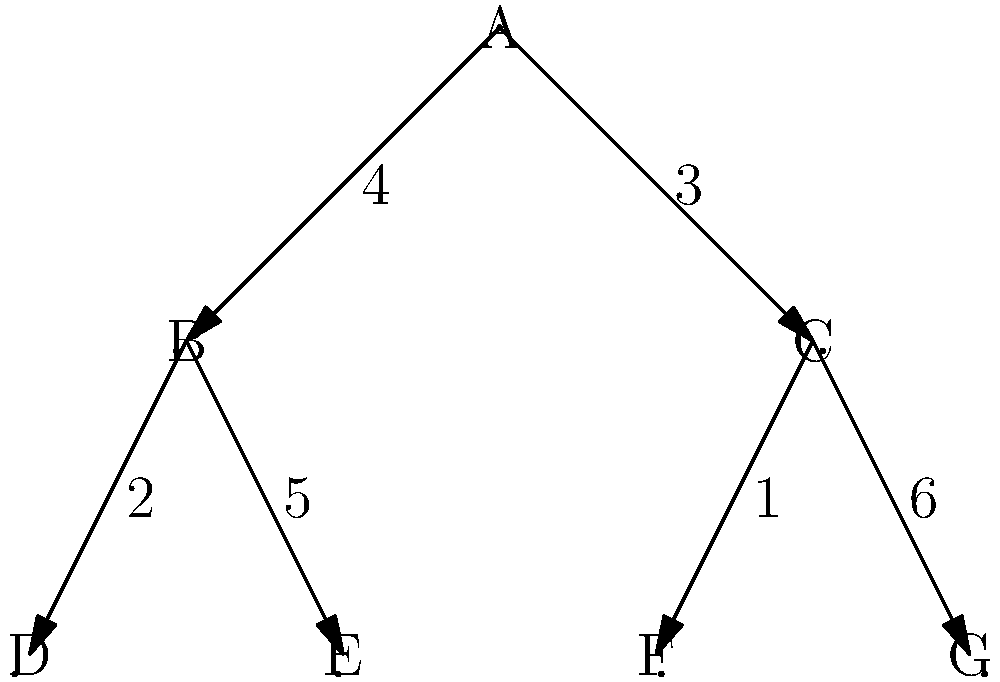Consider the hierarchical organization structure represented by the graph above. Each node represents a department, and the edges represent the flow of resources. The numbers on the edges indicate the maximum resource units that can be allocated through that path. What is the maximum total resource allocation possible from the top-level department A to the bottom-level departments (D, E, F, G), and which path(s) should be prioritized to achieve this optimal allocation? To solve this problem, we'll use the concept of maximum flow in a network. The steps are as follows:

1) Identify the source (A) and sinks (D, E, F, G).

2) Observe that there are two main paths:
   Path 1: A → B → D and E
   Path 2: A → C → F and G

3) Calculate the maximum flow for each path:
   Path 1: The bottleneck is 4 units from A to B.
           - B to D can carry 2 units
           - B to E can carry 5 units
           Total for Path 1 = min(4, 2+5) = 4 units

   Path 2: The bottleneck is 3 units from A to C.
           - C to F can carry 1 unit
           - C to G can carry 6 units
           Total for Path 2 = min(3, 1+6) = 3 units

4) The maximum total resource allocation is the sum of the maximum flows through both paths:
   Maximum total allocation = 4 + 3 = 7 units

5) To achieve this optimal allocation, prioritize:
   - Path A → B → E (4 units)
   - Path A → C → G (3 units)

This allocation fully utilizes the capacity of both main paths from A, ensuring maximum resource distribution to the bottom-level departments.
Answer: 7 units; prioritize A→B→E and A→C→G 